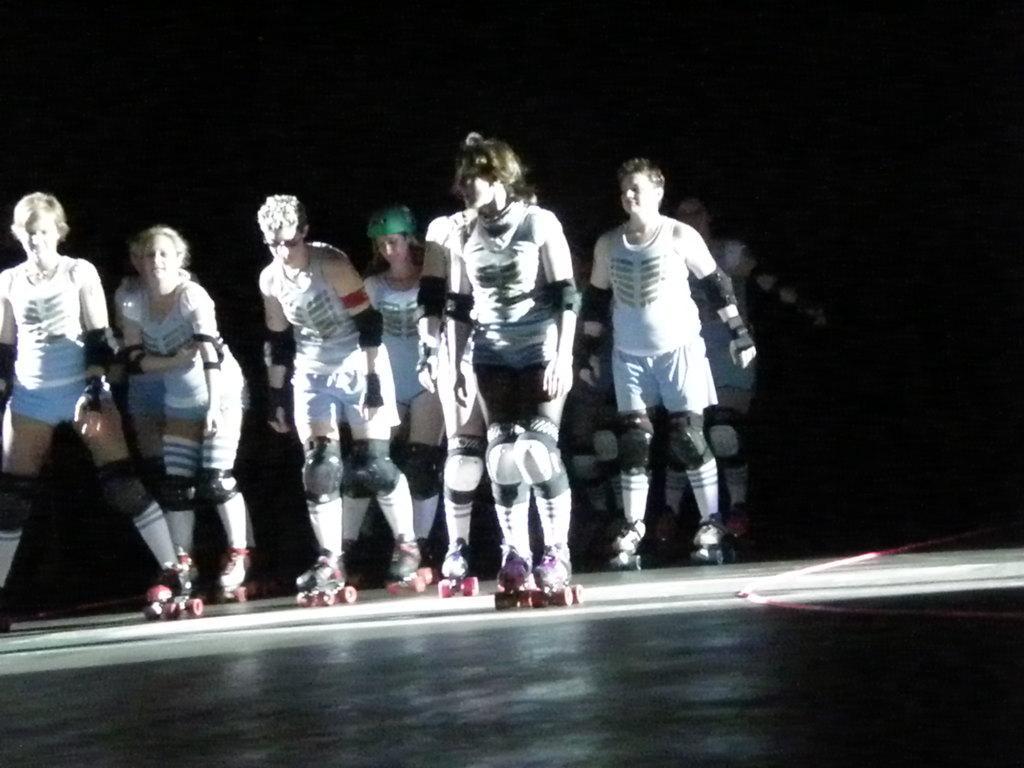In one or two sentences, can you explain what this image depicts? In this picture we can observe some people skating on the skating rink. There are men and women in this picture. All of them were wearing white color dresses. The background is dark. 